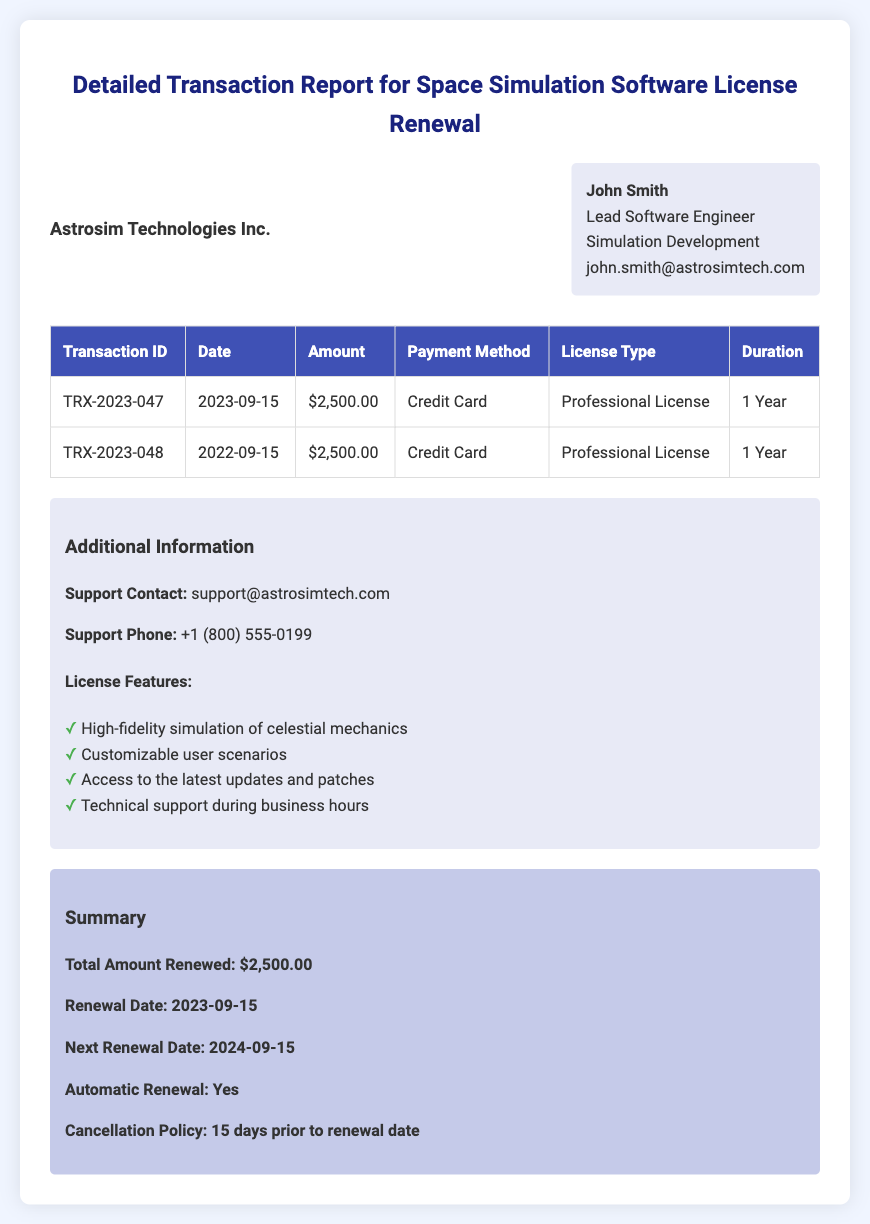What is the total amount renewed? The total amount renewed is explicitly stated in the summary section of the document as $2,500.00.
Answer: $2,500.00 Who is the recipient of this transaction report? The recipient is identified at the top of the document as John Smith, Lead Software Engineer.
Answer: John Smith What is the payment method used for the latest transaction? The payment method is given in the transaction table for the latest entry, which is Credit Card.
Answer: Credit Card When is the next renewal date? The next renewal date is clearly indicated in the summary section as 2024-09-15.
Answer: 2024-09-15 What is the duration of the newly renewed license? The duration of the renewed license is listed in the transaction table as 1 Year.
Answer: 1 Year How many transactions are listed in the document? The document lists two transactions in the transaction table.
Answer: 2 What is the cancellation policy for the license? The cancellation policy is specified in the summary and states that it must be 15 days prior to the renewal date.
Answer: 15 days prior to renewal date What feature allows access to the latest updates? Access to the latest updates and patches is one of the features listed in the additional information.
Answer: Access to the latest updates and patches What is the transaction ID of the first transaction? The transaction ID for the first entry in the transaction table is TRX-2023-047.
Answer: TRX-2023-047 